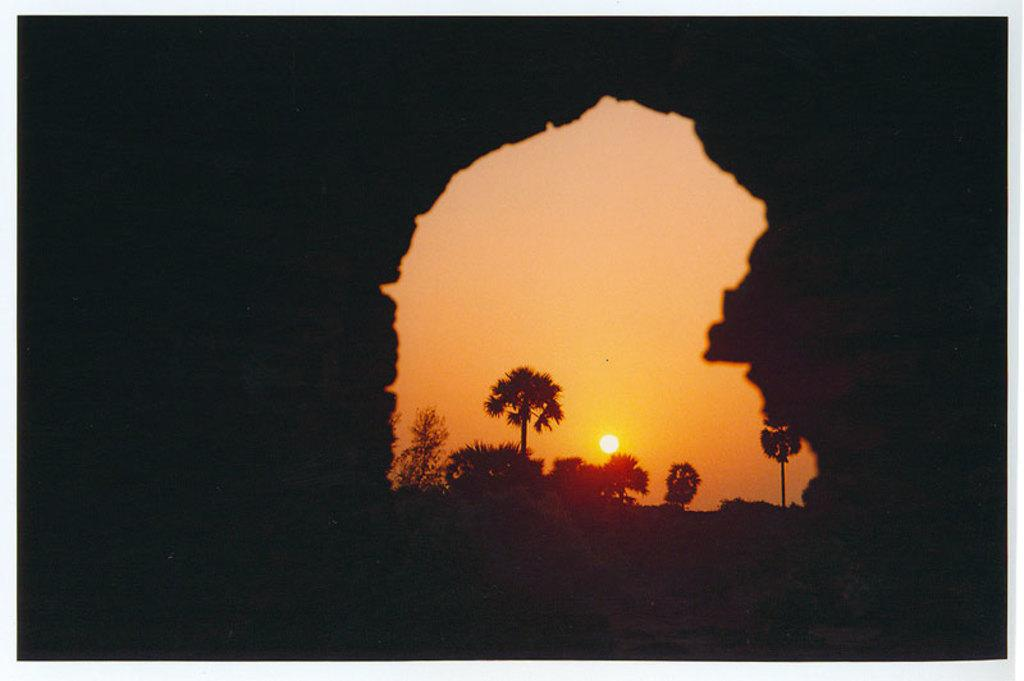What type of vegetation can be seen in the image? There are trees in the image. What is visible in the background of the image? The background of the image includes the sun. What part of the natural environment is visible in the image? The sky is visible in the image. What colors are present in the sky? The sky has orange and yellow colors. How many boats are visible in the image? There are no boats present in the image. What type of nut can be seen growing on the trees in the image? There are no nuts visible in the image, as it only shows trees without any specific details about their fruits or leaves. 